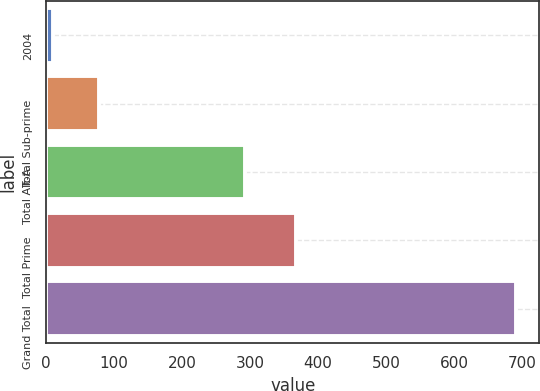Convert chart. <chart><loc_0><loc_0><loc_500><loc_500><bar_chart><fcel>2004<fcel>Total Sub-prime<fcel>Total Alt-A<fcel>Total Prime<fcel>Grand Total<nl><fcel>10<fcel>78.1<fcel>292<fcel>367<fcel>691<nl></chart> 